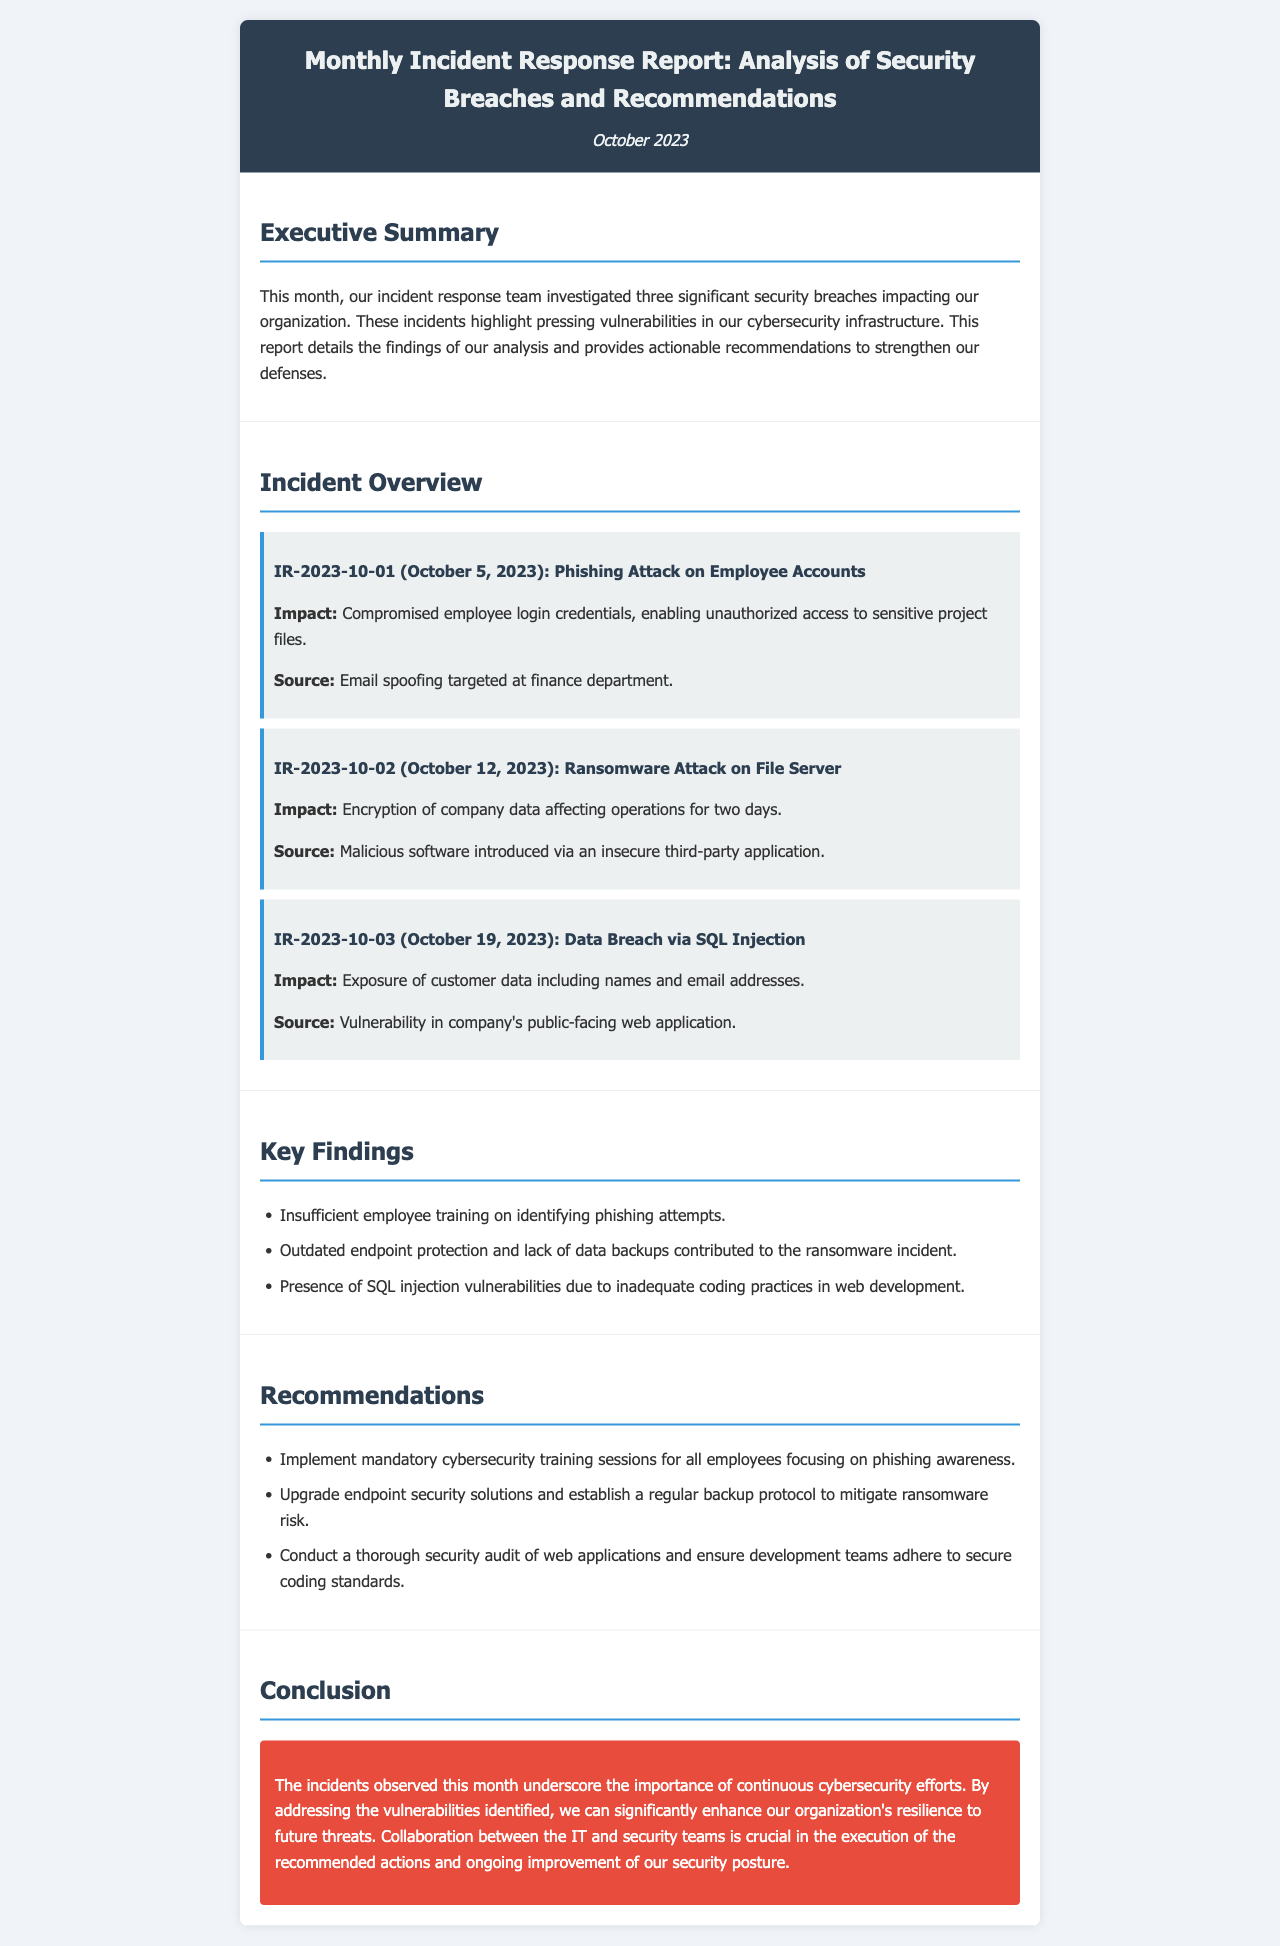What was the date of the phishing attack? The document mentions the phishing attack occurred on October 5, 2023.
Answer: October 5, 2023 How many significant security breaches were investigated this month? The report states that three significant security breaches were investigated.
Answer: Three What was the impact of the ransomware attack? The ransomware attack impacted the encryption of company data affecting operations for two days.
Answer: Encryption of company data affecting operations for two days What is one key finding from the report? One of the key findings highlights insufficient employee training on identifying phishing attempts.
Answer: Insufficient employee training on identifying phishing attempts What type of attack occurred on October 19, 2023? The document specifies that a data breach via SQL injection occurred on that date.
Answer: Data breach via SQL injection What recommendation is suggested for employee training? The recommendations include implementing mandatory cybersecurity training sessions for all employees focusing on phishing awareness.
Answer: Mandatory cybersecurity training sessions for all employees What is the conclusion about cybersecurity efforts? The conclusion emphasizes the importance of continuous cybersecurity efforts to enhance resilience to future threats.
Answer: Continuous cybersecurity efforts What was the source of the ransomware attack? The ransomware attack was introduced via an insecure third-party application.
Answer: Insecure third-party application 